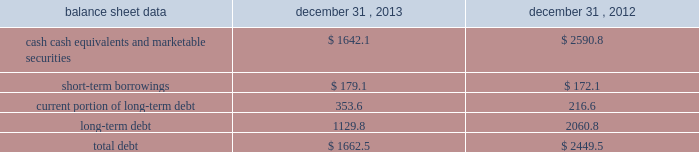Management 2019s discussion and analysis of financial condition and results of operations 2013 ( continued ) ( amounts in millions , except per share amounts ) net cash used in investing activities during 2012 primarily related to payments for capital expenditures and acquisitions , partially offset by the net proceeds of $ 94.8 received from the sale of our remaining holdings in facebook .
Capital expenditures of $ 169.2 primarily related to computer hardware and software , and leasehold improvements .
Capital expenditures increased in 2012 compared to the prior year , primarily due to an increase in leasehold improvements made during the year .
Payments for acquisitions of $ 145.5 primarily related to payments for new acquisitions .
Financing activities net cash used in financing activities during 2013 primarily related to the purchase of long-term debt , the repurchase of our common stock , and payment of dividends .
We redeemed all $ 600.0 in aggregate principal amount of our 10.00% ( 10.00 % ) notes .
In addition , we repurchased 31.8 shares of our common stock for an aggregate cost of $ 481.8 , including fees , and made dividend payments of $ 126.0 on our common stock .
Net cash provided by financing activities during 2012 primarily reflected net proceeds from our debt transactions .
We issued $ 300.0 in aggregate principal amount of 2.25% ( 2.25 % ) senior notes due 2017 ( the 201c2.25% ( 201c2.25 % ) notes 201d ) , $ 500.0 in aggregate principal amount of 3.75% ( 3.75 % ) senior notes due 2023 ( the 201c3.75% ( 201c3.75 % ) notes 201d ) and $ 250.0 in aggregate principal amount of 4.00% ( 4.00 % ) senior notes due 2022 ( the 201c4.00% ( 201c4.00 % ) notes 201d ) .
The proceeds from the issuance of the 4.00% ( 4.00 % ) notes were applied towards the repurchase and redemption of $ 399.6 in aggregate principal amount of our 4.25% ( 4.25 % ) notes .
Offsetting the net proceeds from our debt transactions was the repurchase of 32.7 shares of our common stock for an aggregate cost of $ 350.5 , including fees , and dividend payments of $ 103.4 on our common stock .
Foreign exchange rate changes the effect of foreign exchange rate changes on cash and cash equivalents included in the consolidated statements of cash flows resulted in a decrease of $ 94.1 in 2013 .
The decrease was primarily a result of the u.s .
Dollar being stronger than several foreign currencies , including the australian dollar , brazilian real , japanese yen , canadian dollar and south african rand as of december 31 , 2013 compared to december 31 , 2012 .
The effect of foreign exchange rate changes on cash and cash equivalents included in the consolidated statements of cash flows resulted in a decrease of $ 6.2 in 2012 .
The decrease was a result of the u.s .
Dollar being stronger than several foreign currencies , including the brazilian real and south african rand , offset by the u.s .
Dollar being weaker than other foreign currencies , including the australian dollar , british pound and the euro , as of as of december 31 , 2012 compared to december 31 , 2011. .
Liquidity outlook we expect our cash flow from operations , cash and cash equivalents to be sufficient to meet our anticipated operating requirements at a minimum for the next twelve months .
We also have a committed corporate credit facility as well as uncommitted facilities available to support our operating needs .
We continue to maintain a disciplined approach to managing liquidity , with flexibility over significant uses of cash , including our capital expenditures , cash used for new acquisitions , our common stock repurchase program and our common stock dividends. .
How much more of a decrease cash was a result of foreign exchange in 2013 compared to 2012? 
Rationale: to get the difference between 2012 and 2013 loss of cash due to foreign exchange rates , one must subtract the loss of 2013 by the loss of 2012 to get $ 87.9 million .
Computations: (94.1 - 6.2)
Answer: 87.9. 